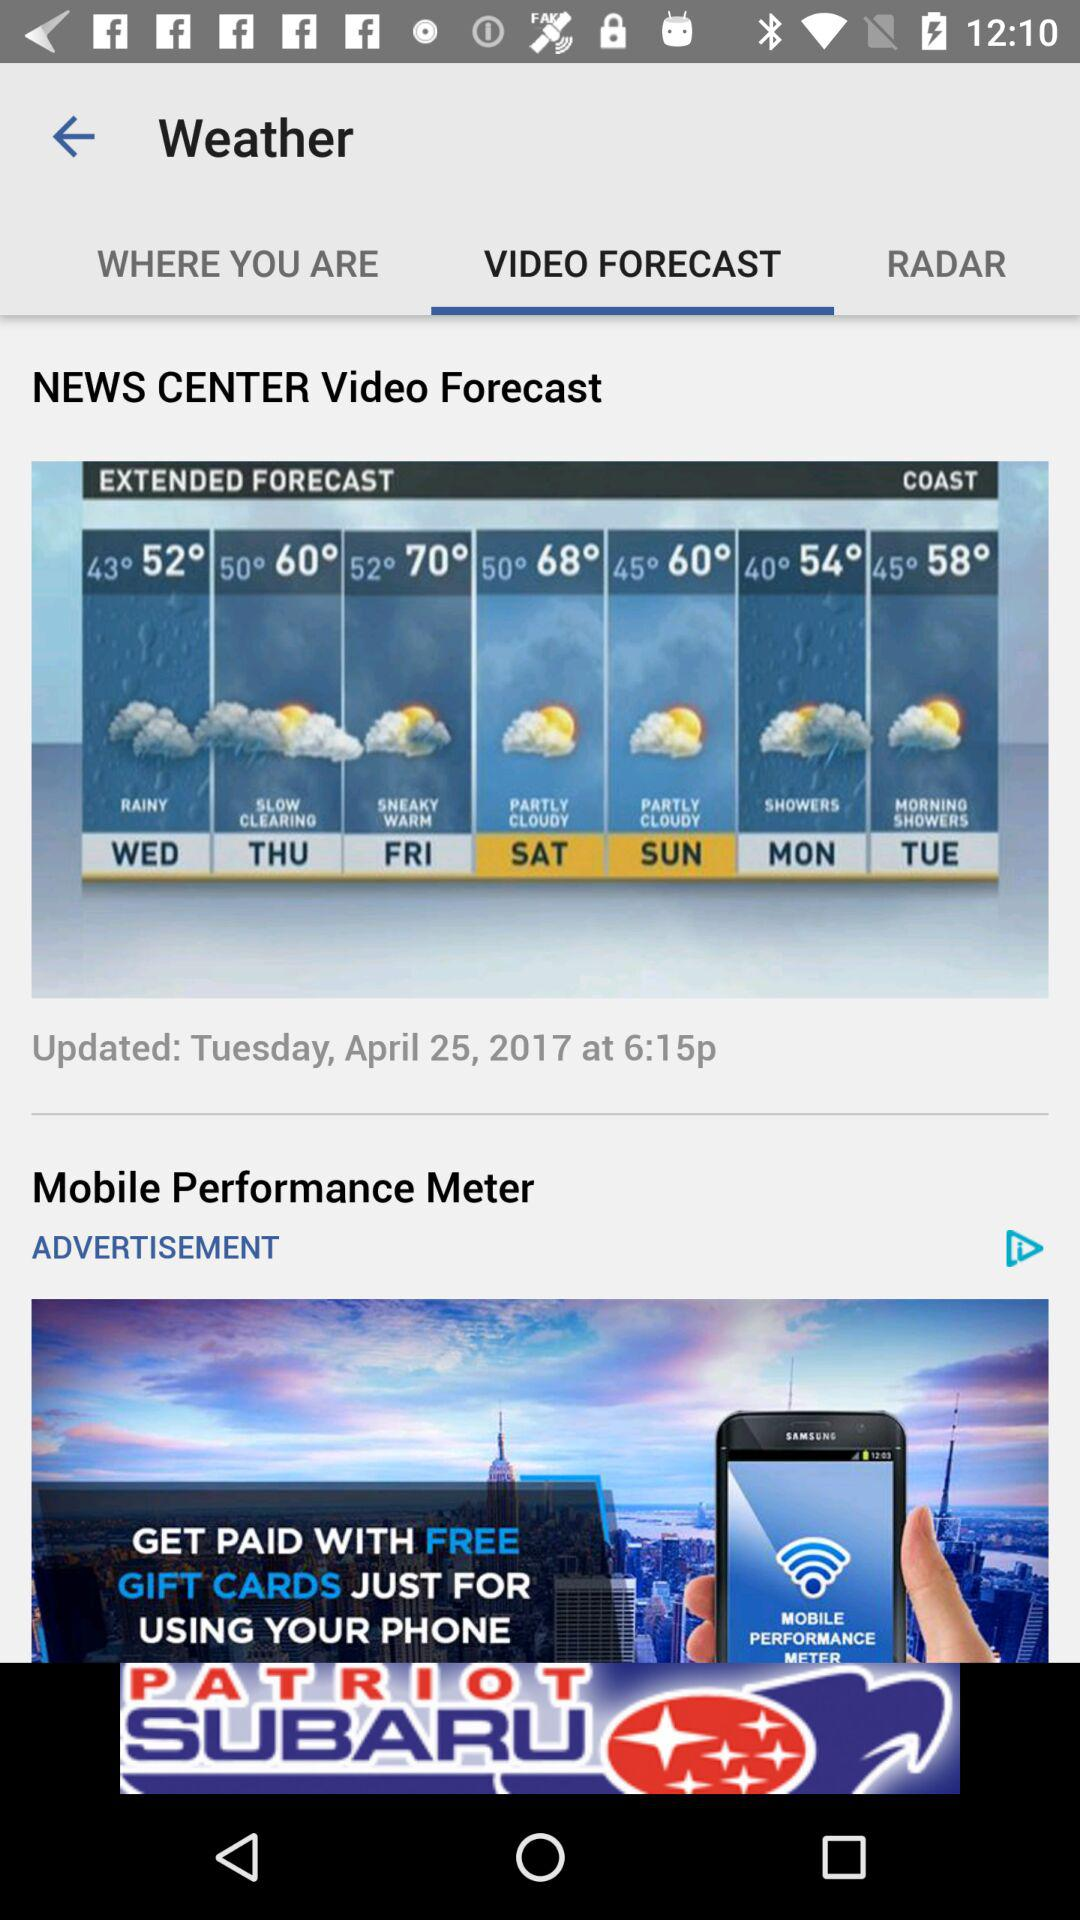Which tab is selected? The selected tab is "VIDEO FORECAST". 